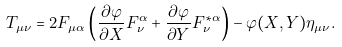Convert formula to latex. <formula><loc_0><loc_0><loc_500><loc_500>T _ { \mu \nu } = 2 F _ { \mu \alpha } \left ( \frac { \partial \varphi } { \partial X } F _ { \nu } ^ { \alpha } + \frac { \partial \varphi } { \partial Y } F _ { \nu } ^ { * \alpha } \right ) - \varphi ( X , Y ) \eta _ { \mu \nu } .</formula> 